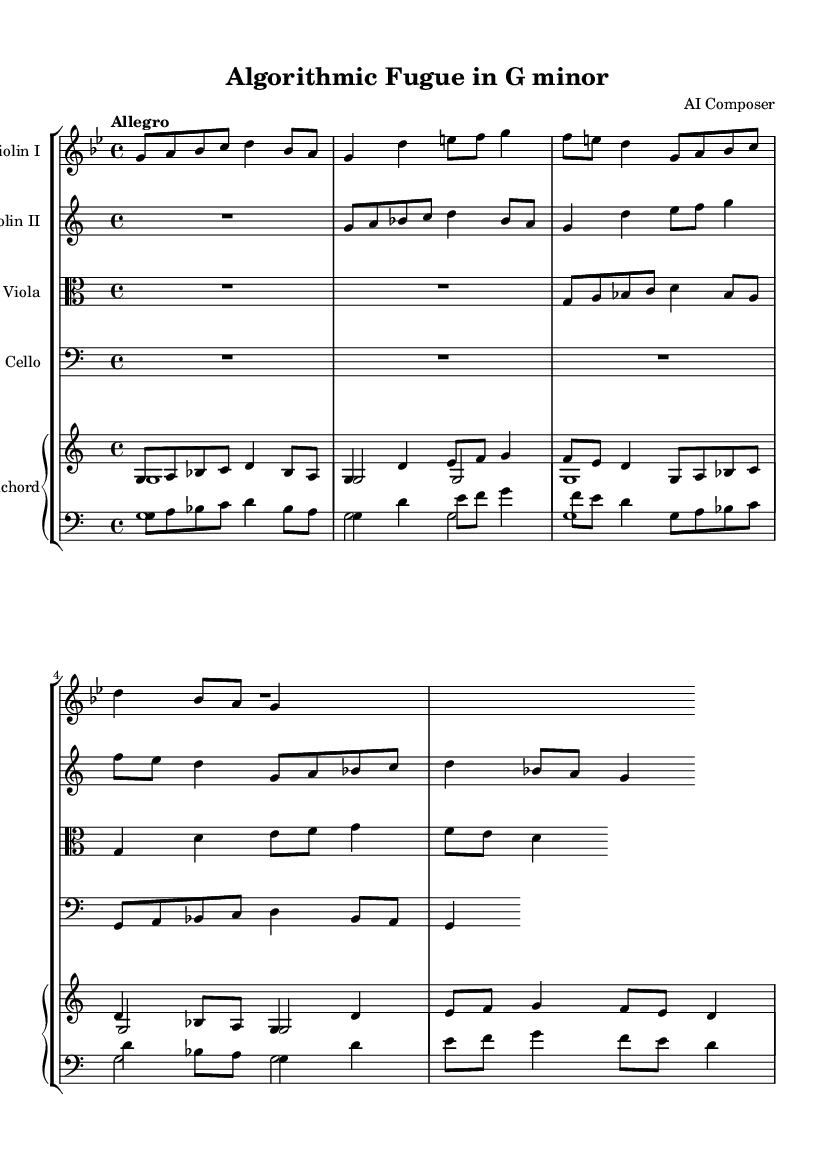What is the key signature of this music? The key signature is indicated at the beginning of the staff. In this case, it is G minor, which has two flats.
Answer: G minor What is the time signature of this music? The time signature is notated at the beginning of the piece. Here, it is 4/4, meaning there are four beats per measure.
Answer: 4/4 What is the tempo marking for this piece? The tempo is indicated at the beginning with the word "Allegro," suggesting a fast-paced performance.
Answer: Allegro How many measures does the first violin part contain? By counting the distinct measure lines in the violin I part, we see there are a total of 3 measures.
Answer: 3 Which instrument plays a sustained note throughout the beginning sections? Observing the sheet music, the cello part holds rests initially and plays only in the last section, meaning it does not play sustained notes at the beginning. Thus, the harpsichord plays sustained notes in the lower register.
Answer: Harpsichord What is the unique structural feature found in the composition? This piece features a fugal structure, which is characteristic of Baroque music. The use of multiple voices weaving in and out with similar melodic lines creates a complex interweaving, typical for fugal works.
Answer: Fugal structure How does the harmony behave in this piece? Looking at the harmony, the use of parallel motion and the bass lines moving in a consistent manner indicates an algorithmic-like structure. This simple, repetitive pattern, coupled with varying melodic lines in the other instruments, reinforces tension and resolution.
Answer: Algorithmic-like harmony 